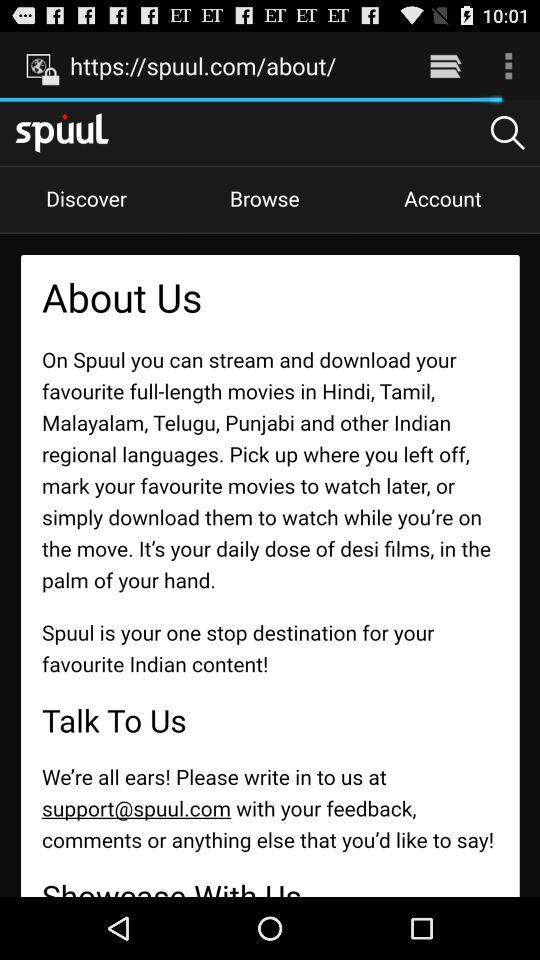What is the website name? The website name is spuul.com. 